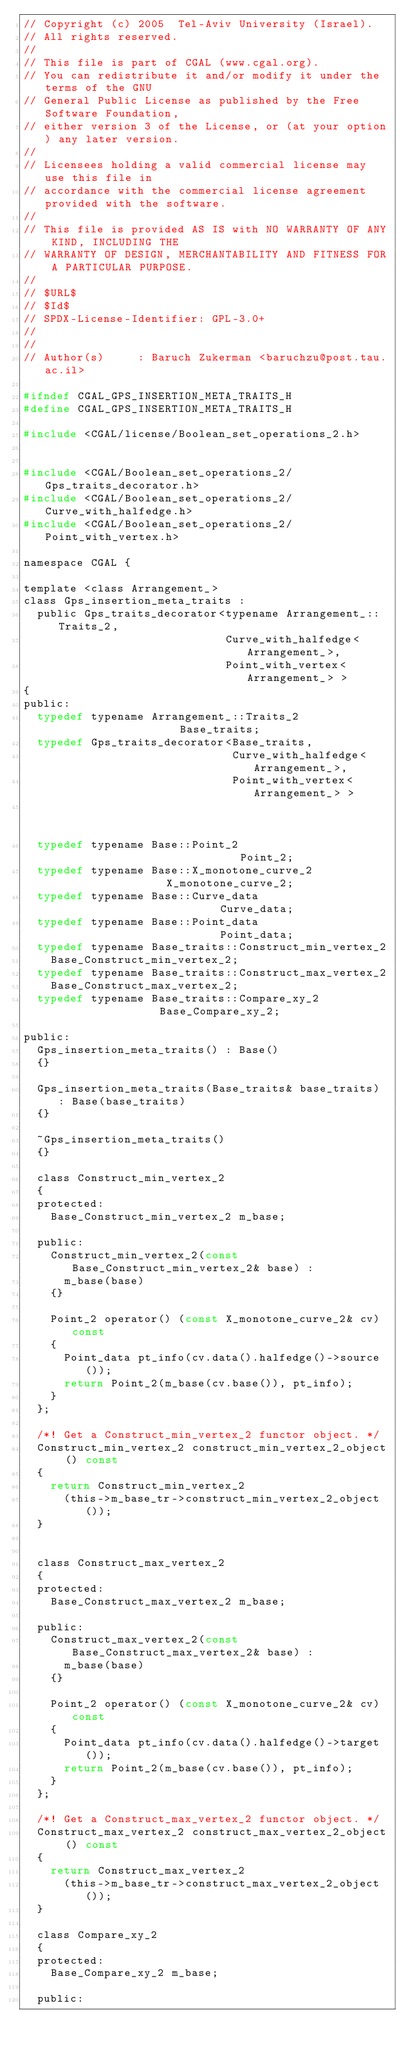<code> <loc_0><loc_0><loc_500><loc_500><_C_>// Copyright (c) 2005  Tel-Aviv University (Israel).
// All rights reserved.
//
// This file is part of CGAL (www.cgal.org).
// You can redistribute it and/or modify it under the terms of the GNU
// General Public License as published by the Free Software Foundation,
// either version 3 of the License, or (at your option) any later version.
//
// Licensees holding a valid commercial license may use this file in
// accordance with the commercial license agreement provided with the software.
//
// This file is provided AS IS with NO WARRANTY OF ANY KIND, INCLUDING THE
// WARRANTY OF DESIGN, MERCHANTABILITY AND FITNESS FOR A PARTICULAR PURPOSE.
//
// $URL$
// $Id$
// SPDX-License-Identifier: GPL-3.0+
// 
//
// Author(s)     : Baruch Zukerman <baruchzu@post.tau.ac.il>

#ifndef CGAL_GPS_INSERTION_META_TRAITS_H
#define CGAL_GPS_INSERTION_META_TRAITS_H

#include <CGAL/license/Boolean_set_operations_2.h>


#include <CGAL/Boolean_set_operations_2/Gps_traits_decorator.h>
#include <CGAL/Boolean_set_operations_2/Curve_with_halfedge.h>
#include <CGAL/Boolean_set_operations_2/Point_with_vertex.h>

namespace CGAL {

template <class Arrangement_>
class Gps_insertion_meta_traits : 
  public Gps_traits_decorator<typename Arrangement_::Traits_2,
                              Curve_with_halfedge<Arrangement_>,
                              Point_with_vertex<Arrangement_> >
{
public:
  typedef typename Arrangement_::Traits_2                   Base_traits;
  typedef Gps_traits_decorator<Base_traits,
                               Curve_with_halfedge<Arrangement_>,
                               Point_with_vertex<Arrangement_> >
                                                            Base;
  typedef typename Base::Point_2                            Point_2; 
  typedef typename Base::X_monotone_curve_2                 X_monotone_curve_2; 
  typedef typename Base::Curve_data                         Curve_data;
  typedef typename Base::Point_data                         Point_data;
  typedef typename Base_traits::Construct_min_vertex_2
    Base_Construct_min_vertex_2;
  typedef typename Base_traits::Construct_max_vertex_2
    Base_Construct_max_vertex_2;
  typedef typename Base_traits::Compare_xy_2                Base_Compare_xy_2;

public:
  Gps_insertion_meta_traits() : Base()
  {}

  Gps_insertion_meta_traits(Base_traits& base_traits) : Base(base_traits)
  {}

  ~Gps_insertion_meta_traits()
  {}

  class Construct_min_vertex_2
  {
  protected:
    Base_Construct_min_vertex_2 m_base;

  public:
    Construct_min_vertex_2(const Base_Construct_min_vertex_2& base) :
      m_base(base)
    {}

    Point_2 operator() (const X_monotone_curve_2& cv) const
    {
      Point_data pt_info(cv.data().halfedge()->source());
      return Point_2(m_base(cv.base()), pt_info);
    }
  };

  /*! Get a Construct_min_vertex_2 functor object. */
  Construct_min_vertex_2 construct_min_vertex_2_object () const
  {
    return Construct_min_vertex_2
      (this->m_base_tr->construct_min_vertex_2_object());
  }


  class Construct_max_vertex_2
  {
  protected:
    Base_Construct_max_vertex_2 m_base;

  public:
    Construct_max_vertex_2(const Base_Construct_max_vertex_2& base) :
      m_base(base)
    {}

    Point_2 operator() (const X_monotone_curve_2& cv) const
    {
      Point_data pt_info(cv.data().halfedge()->target());
      return Point_2(m_base(cv.base()), pt_info);
    }
  };

  /*! Get a Construct_max_vertex_2 functor object. */
  Construct_max_vertex_2 construct_max_vertex_2_object () const
  {
    return Construct_max_vertex_2
      (this->m_base_tr->construct_max_vertex_2_object());
  }

  class Compare_xy_2
  {
  protected:
    Base_Compare_xy_2 m_base;

  public:</code> 